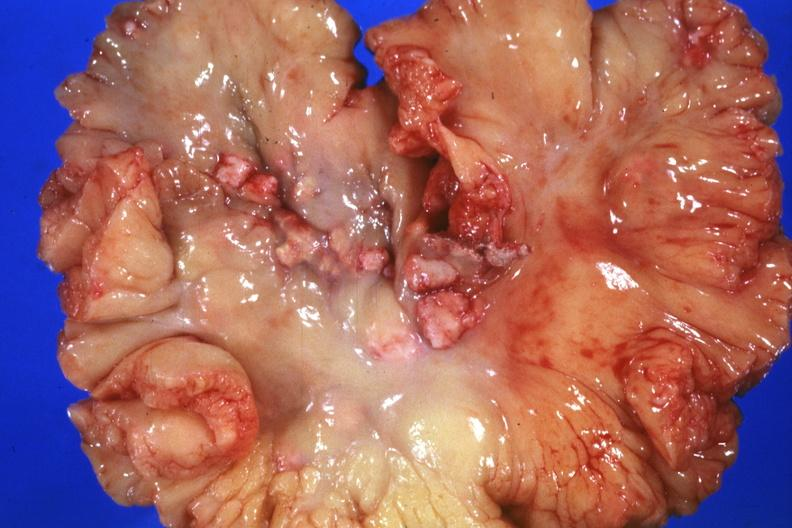s lymph node present?
Answer the question using a single word or phrase. Yes 